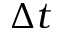Convert formula to latex. <formula><loc_0><loc_0><loc_500><loc_500>\Delta t</formula> 